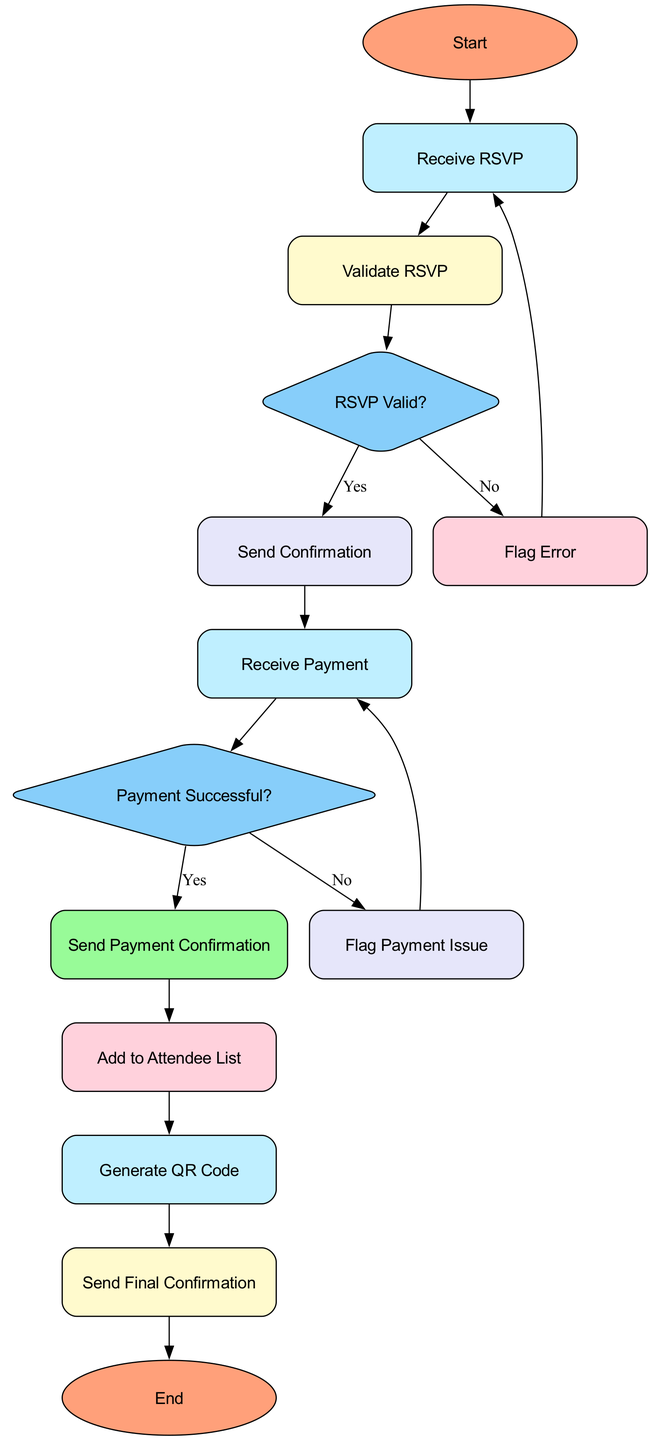What is the first step in the process? The flowchart starts with the terminal node named "Start," which indicates the beginning of the event registration process.
Answer: Start How many decision nodes are in the diagram? The flowchart includes two decision nodes: "RSVP Valid?" and "Payment Successful?" which assess specific conditions in the process.
Answer: 2 What node comes after "Validate RSVP"? The next node that follows "Validate RSVP" is the decision node titled "RSVP Valid?", which checks if the RSVP information is valid.
Answer: RSVP Valid? What happens if the RSVP information is invalid? If the RSVP information is deemed invalid (No from "RSVP Valid?"), the flow goes to "Flag Error," which notifies the fan about the incomplete or incorrect RSVP.
Answer: Flag Error What must be processed after receiving payment? After receiving payment, the next step is to verify payment success with the decision node "Payment Successful?" to check if the transaction was completed successfully.
Answer: Payment Successful? What is the final step of the registration process? The last step in the process, noted in the flowchart, is the terminal node called "End," which signifies the completion of the event registration process.
Answer: End What is the outcome if payment fails? If the payment is unsuccessful (No from "Payment Successful?"), the process loops back to "Receive Payment," indicating that the fan needs to retry the payment.
Answer: Receive Payment Which node sends the final confirmation? The process of sending the final confirmation is handled by the node "Send Final Confirmation," which provides event details and the QR code to the fan.
Answer: Send Final Confirmation What leads to adding a fan to the attendee list? The addition of a fan's details to the attendee list occurs after the successful payment confirmation is sent, which is indicated by the "Send Payment Confirmation" node.
Answer: Add to Attendee List 